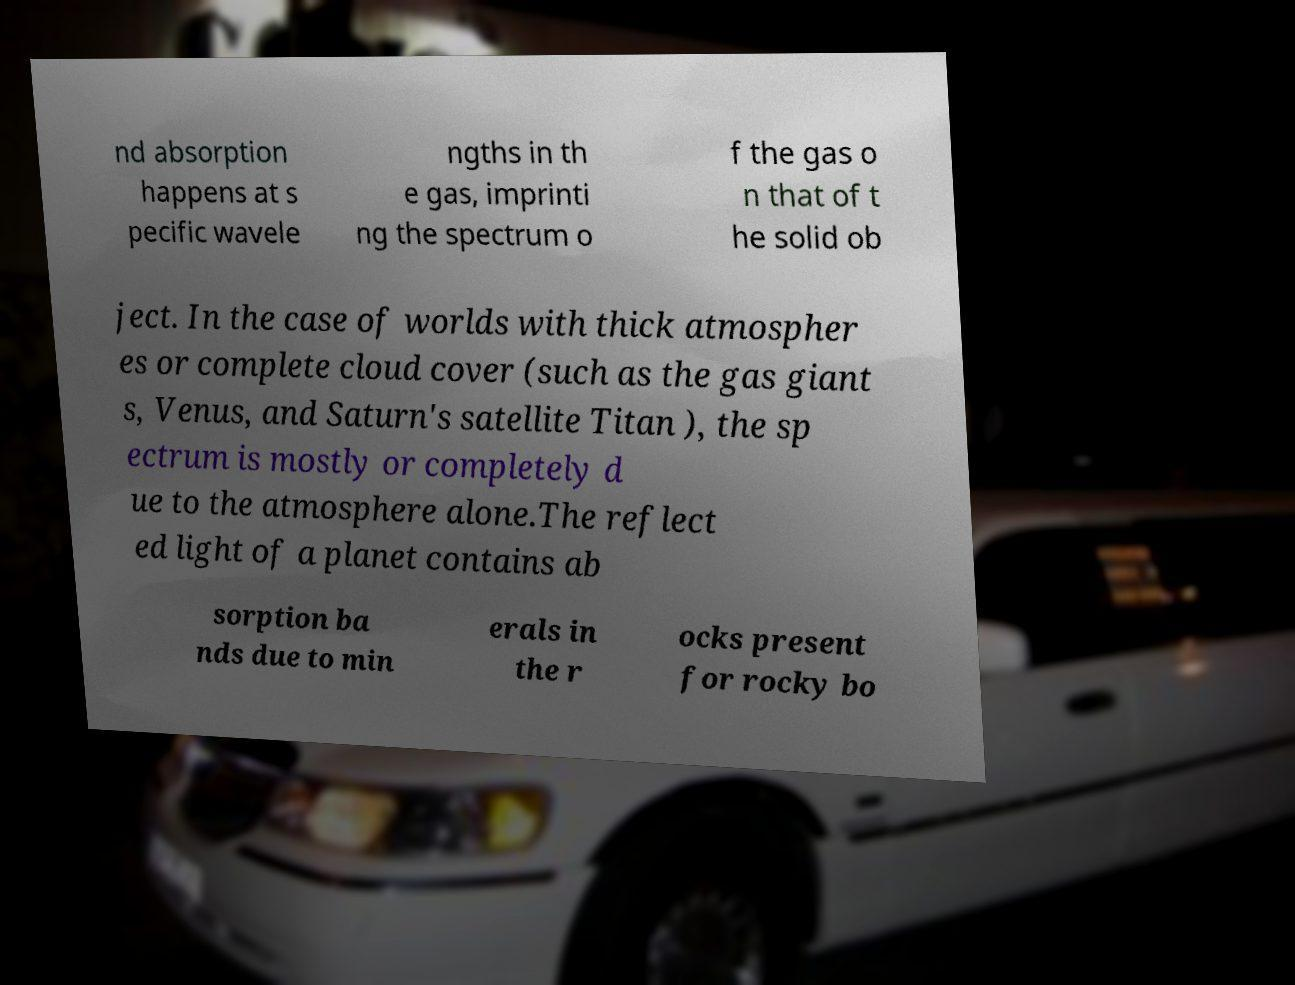Can you read and provide the text displayed in the image?This photo seems to have some interesting text. Can you extract and type it out for me? nd absorption happens at s pecific wavele ngths in th e gas, imprinti ng the spectrum o f the gas o n that of t he solid ob ject. In the case of worlds with thick atmospher es or complete cloud cover (such as the gas giant s, Venus, and Saturn's satellite Titan ), the sp ectrum is mostly or completely d ue to the atmosphere alone.The reflect ed light of a planet contains ab sorption ba nds due to min erals in the r ocks present for rocky bo 